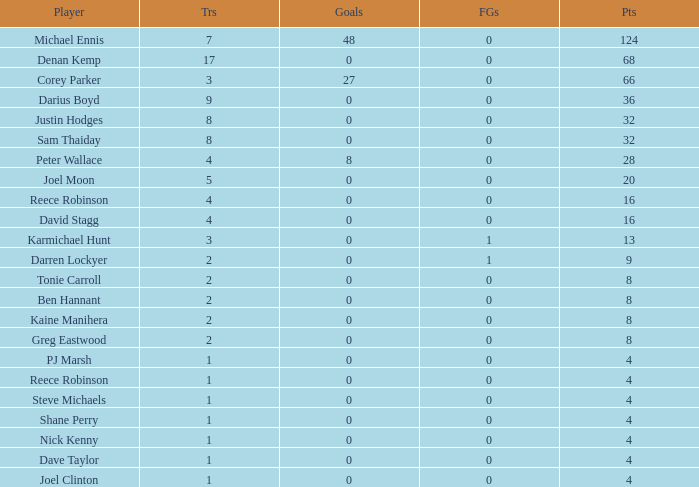What is the total number of field goals of Denan Kemp, who has more than 4 tries, more than 32 points, and 0 goals? 1.0. 